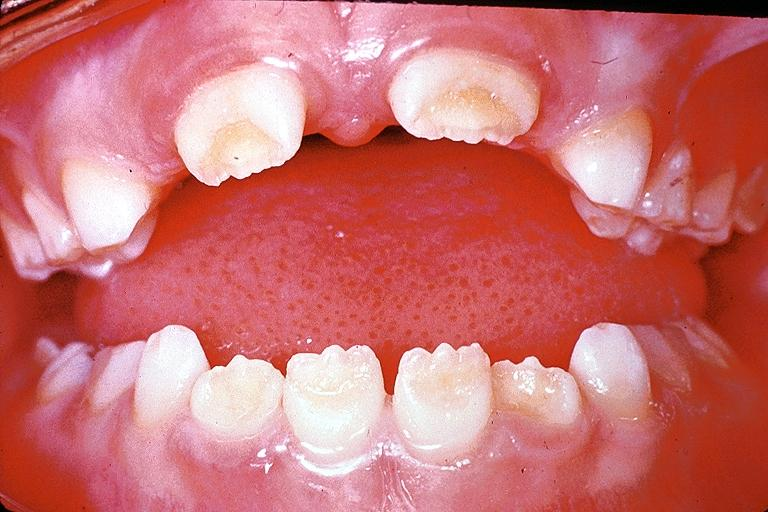where is this?
Answer the question using a single word or phrase. Oral 